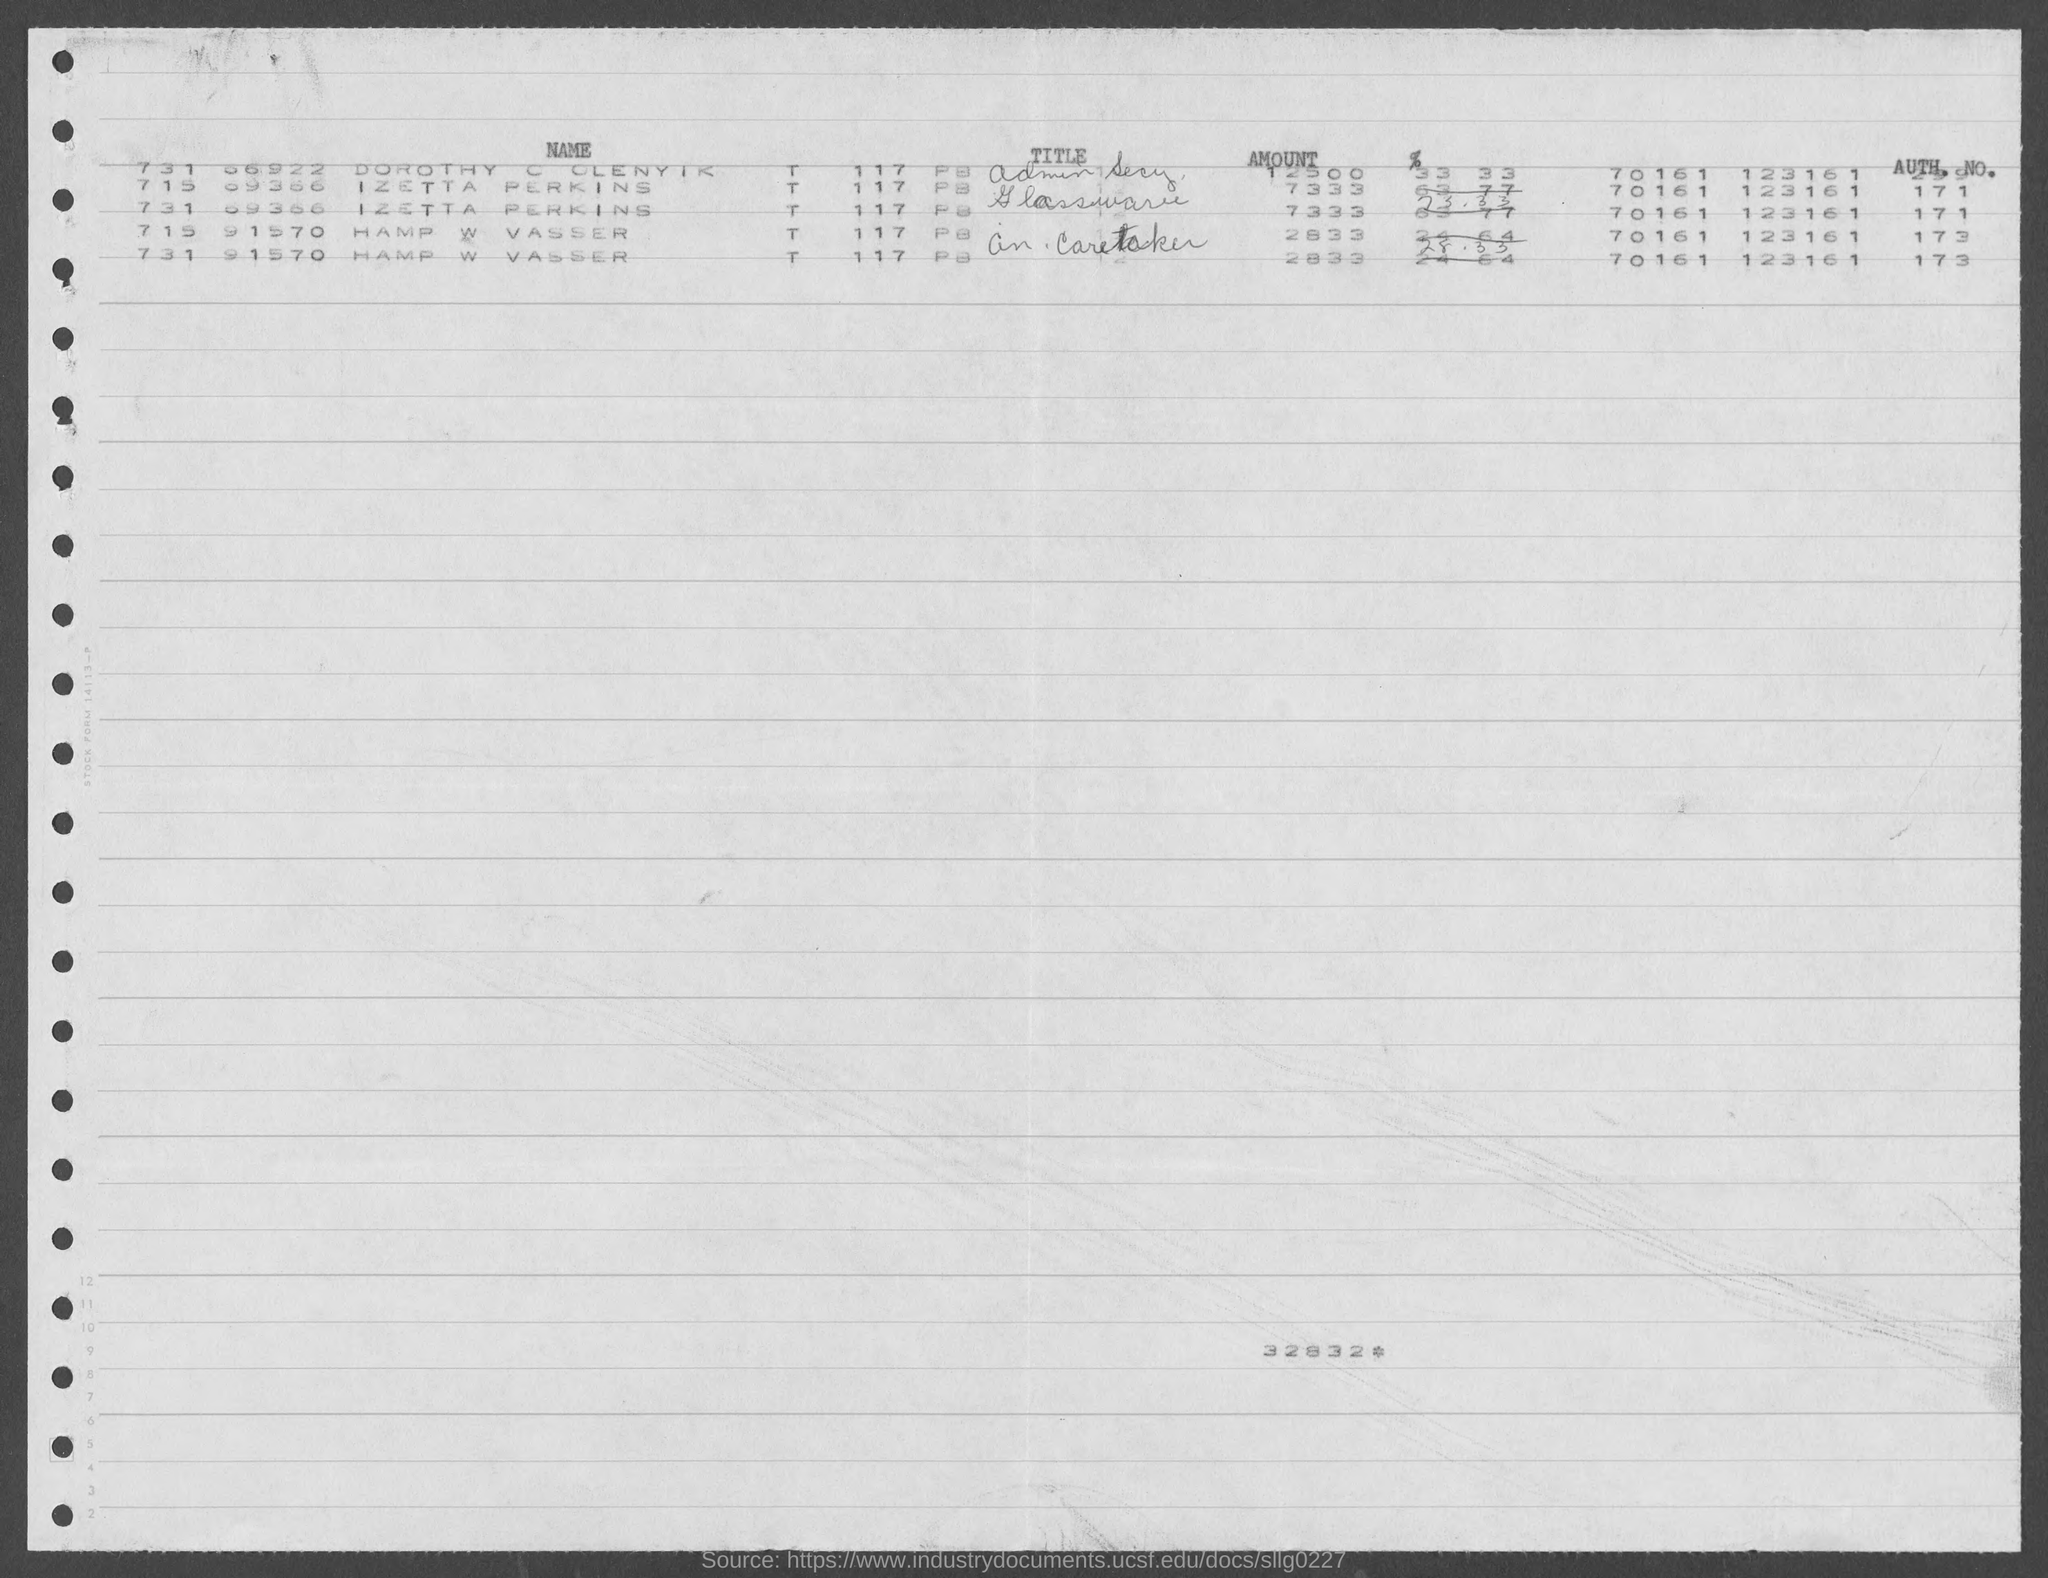Indicate a few pertinent items in this graphic. The amount is 7333, as declared by Izetta Perkins. The amount of Hampt W Vasser is 2833. The number at the bottom of the document is 32,832. The authorized number of Izetta Perkins is 171. The authorized number of Hamp W Vasser is 173. 